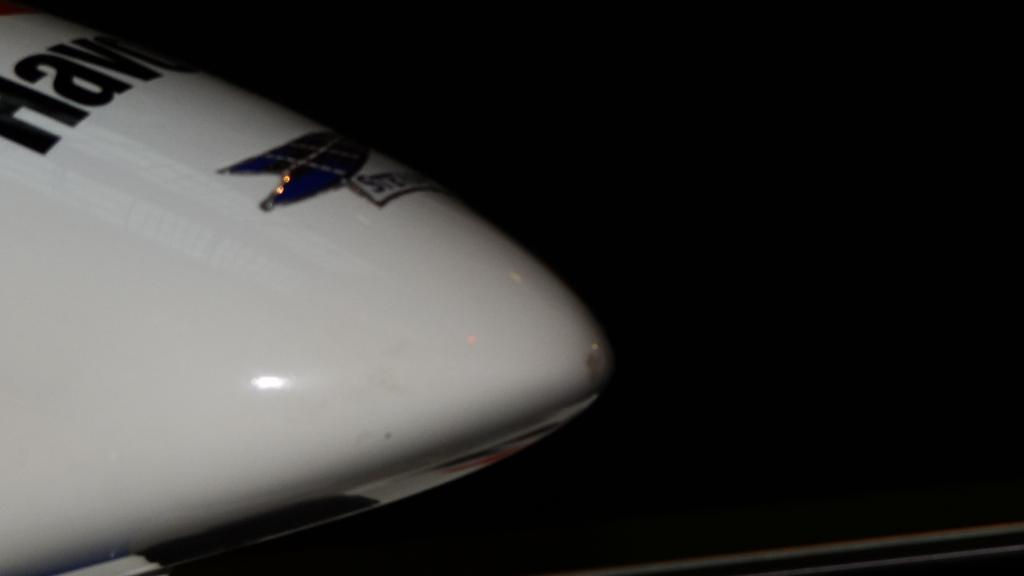What is the main subject on the left side of the image? There is a white object on the left side of the image. What is written or depicted on the white object? There is text on the white object. How would you describe the overall appearance of the image? The background of the image is very dark. What type of wool is being spun by the bird in the image? There is no bird or wool present in the image; it only features a white object with text and a dark background. 